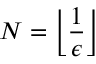<formula> <loc_0><loc_0><loc_500><loc_500>N = \left \lfloor { \frac { 1 } { \epsilon } } \right \rfloor</formula> 